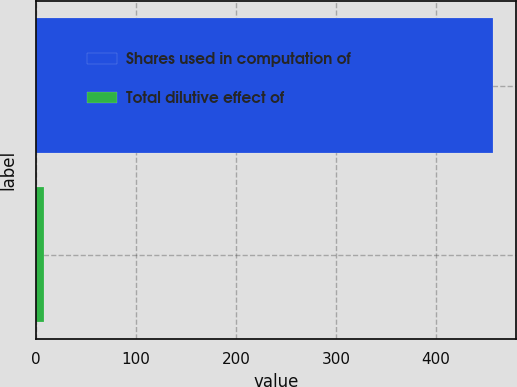<chart> <loc_0><loc_0><loc_500><loc_500><bar_chart><fcel>Shares used in computation of<fcel>Total dilutive effect of<nl><fcel>457.6<fcel>8<nl></chart> 